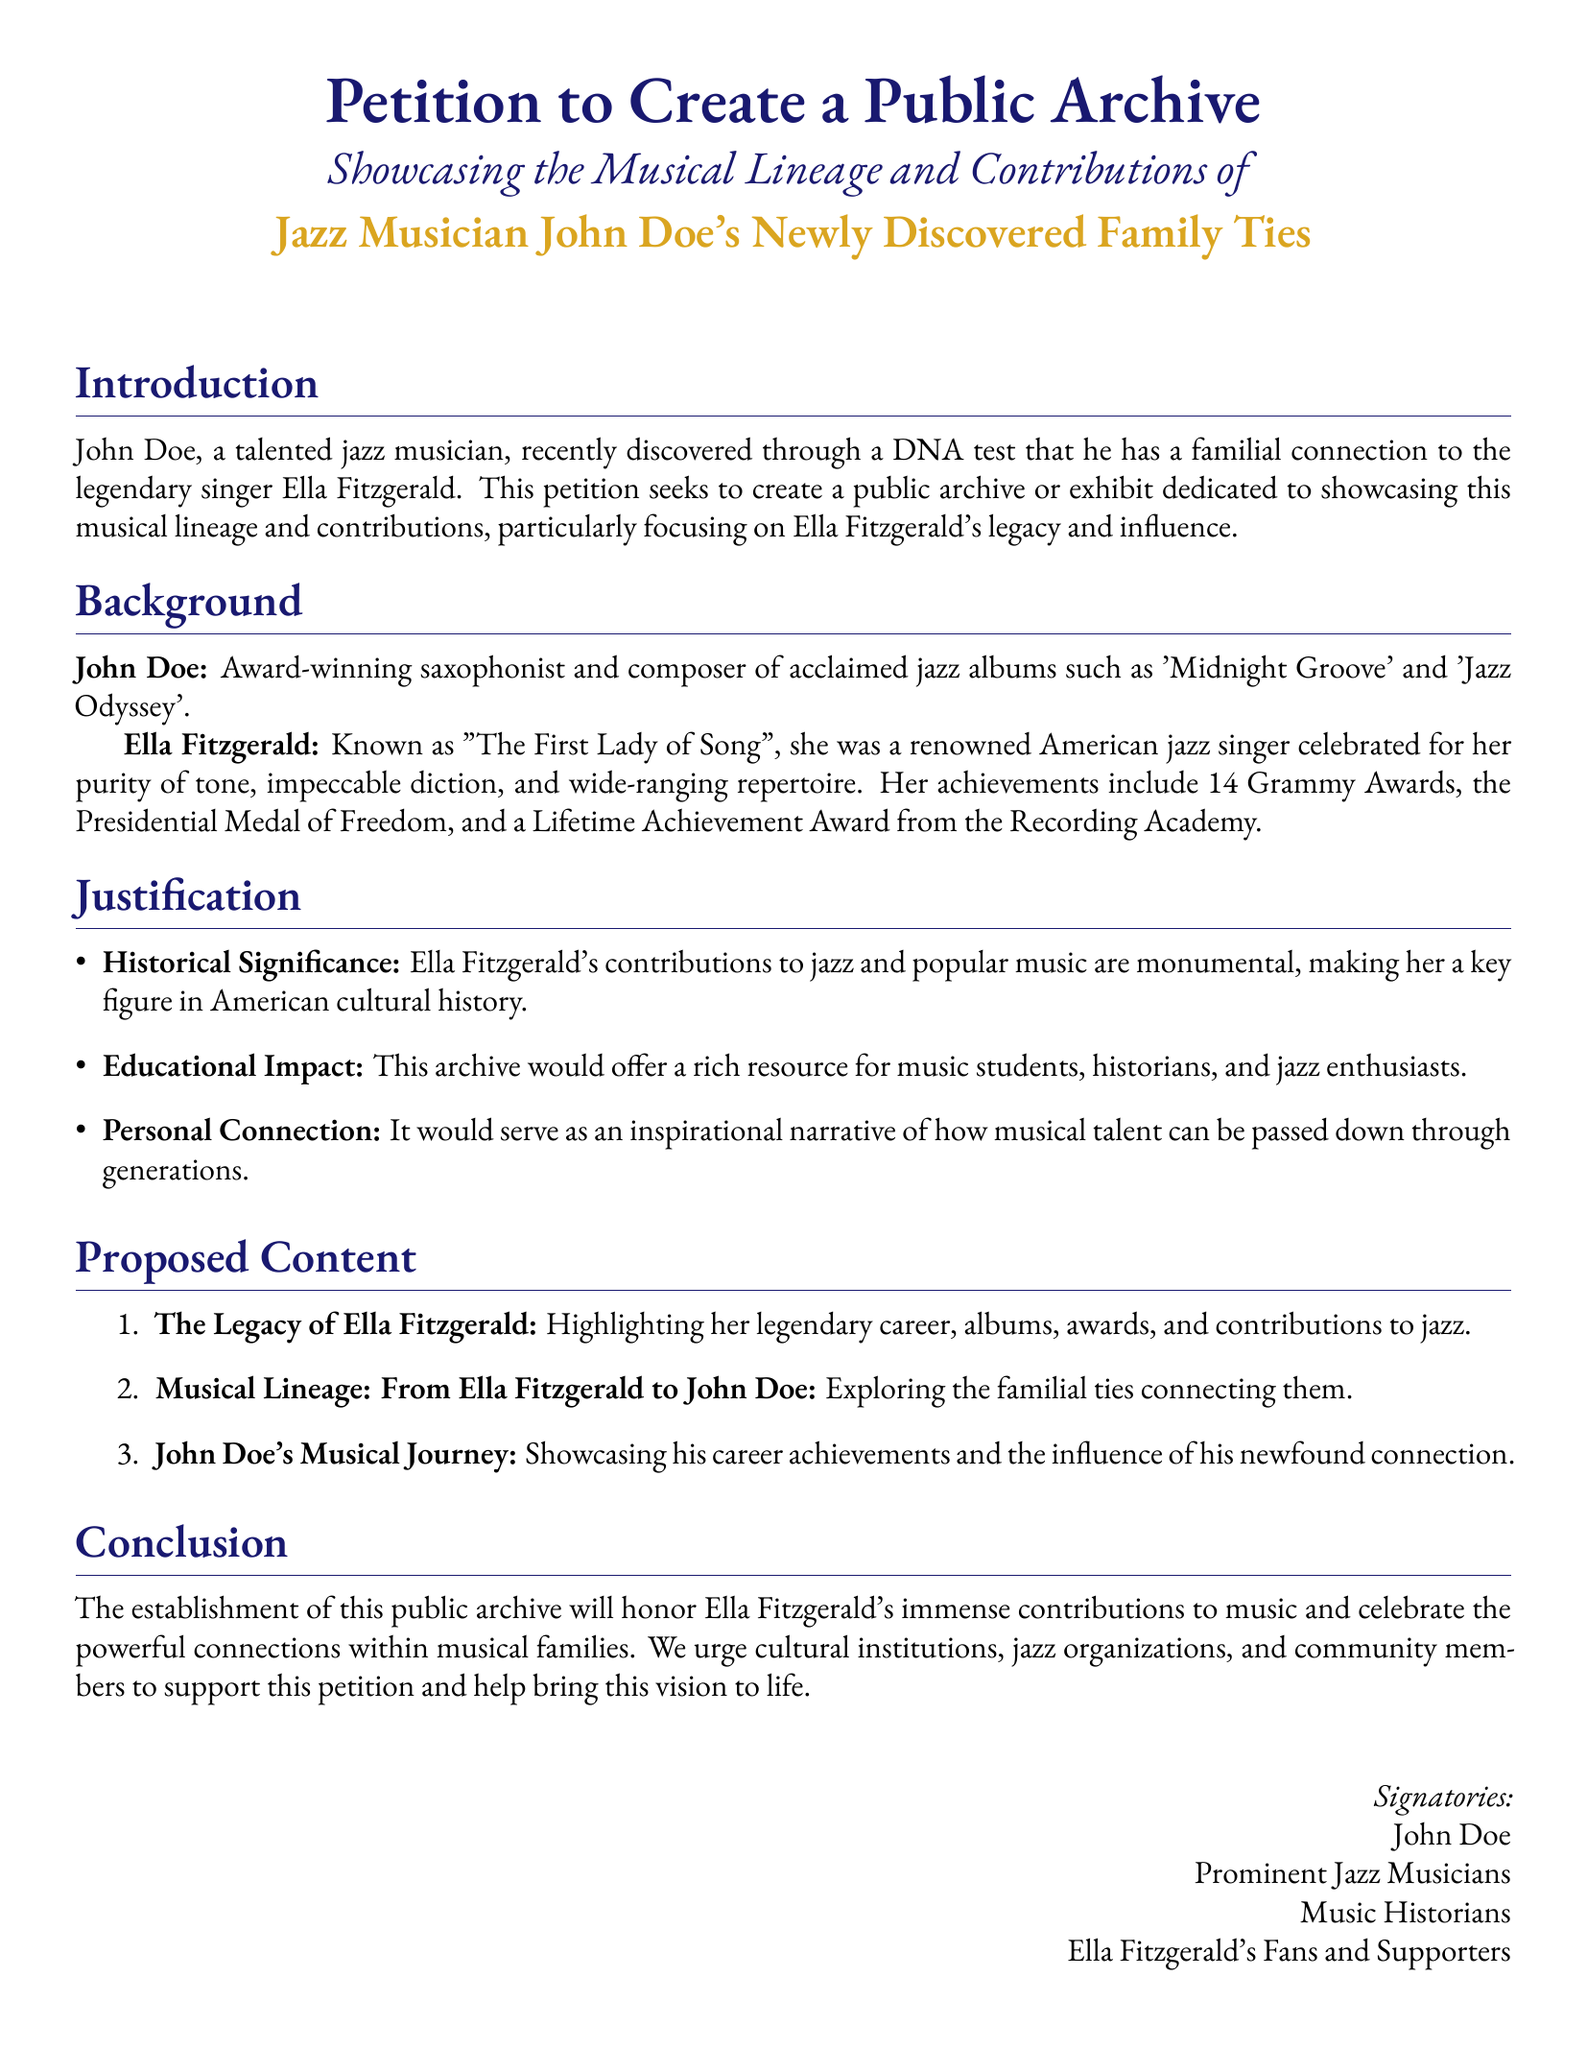What is the purpose of the petition? The petition seeks to create a public archive or exhibit showcasing the musical lineage and contributions of John Doe's newly discovered family ties.
Answer: Create a public archive Who is the legendary singer connected to John Doe? The document mentions that John Doe has a familial connection to the legendary singer.
Answer: Ella Fitzgerald How many Grammy Awards did Ella Fitzgerald win? The document specifies the number of Grammy Awards won by Ella Fitzgerald.
Answer: 14 What are the titles of John Doe's acclaimed jazz albums? The petition lists the names of John Doe's jazz albums as part of his background information.
Answer: Midnight Groove, Jazz Odyssey What would the archive offer to students and historians? The document specifies what the archive would provide to music students and historians.
Answer: A rich resource What impact would the petition have on musical families? The conclusion explains the significance of the archival project concerning musical families.
Answer: Celebrate powerful connections What type of musician is John Doe? The petition describes his professional background specifically as a type.
Answer: Jazz musician Name one of the awards received by Ella Fitzgerald. The background section lists several achievements of Ella Fitzgerald, including awards.
Answer: Presidential Medal of Freedom 